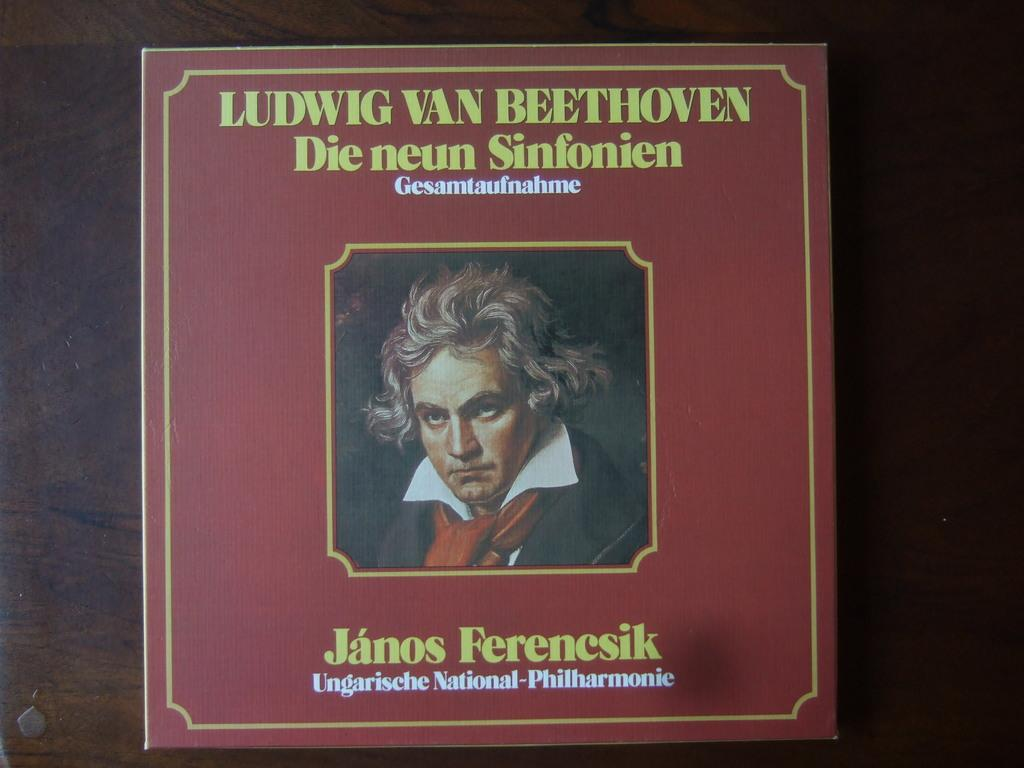What is the main object in the image? There is a board in the image. What is depicted on the board? The board has a picture of a person on it. Are there any words or letters on the board? Yes, there is text on the board. On what surface is the board placed? The board is placed on a surface. Can you tell me how the person on the board is reading the text? There is no indication in the image that the person on the board is reading the text, as the person is a static image on the board. 